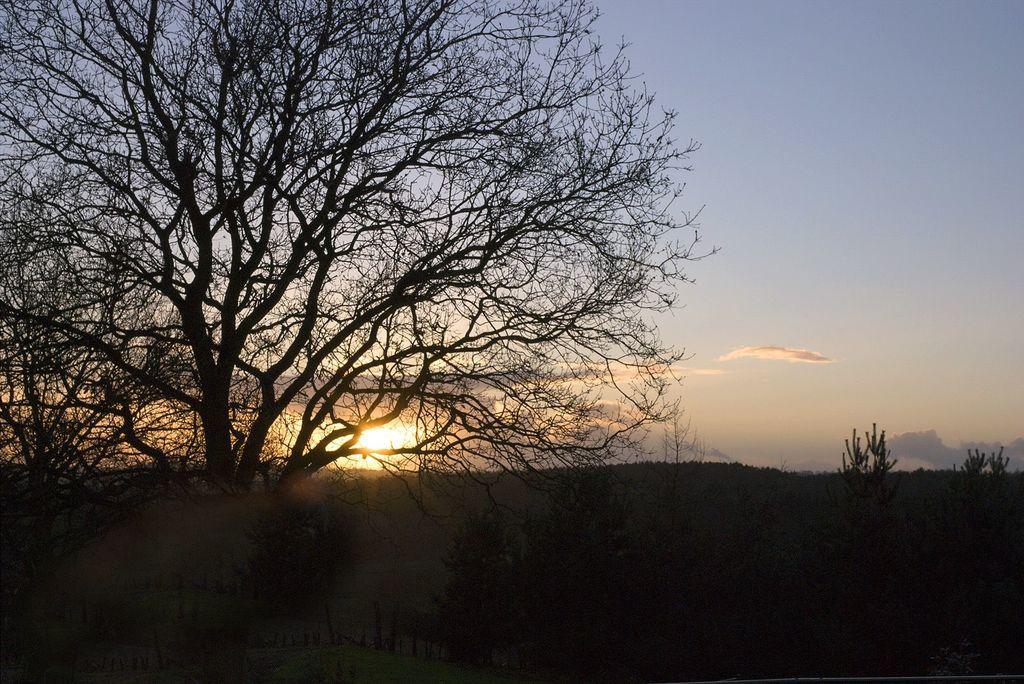Can you describe this image briefly? In the foreground of the picture we can see trees. At the bottom it is dark. In the background we can see sky and sun. 